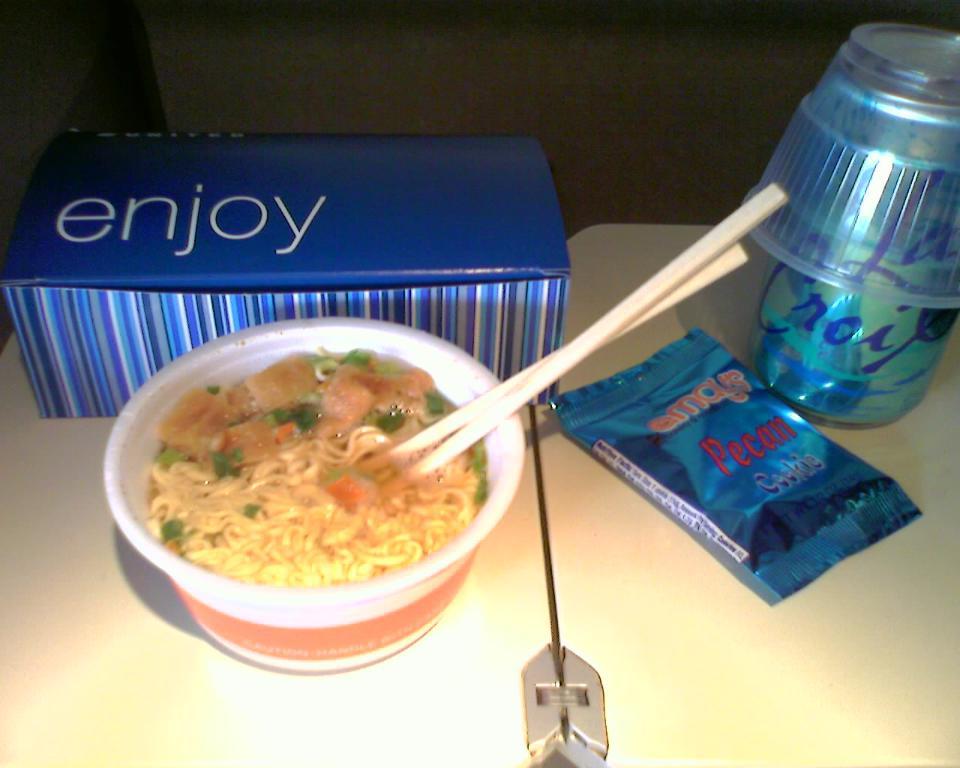What nuts are in the package to the right of the noddles?
Your response must be concise. Pecan. 